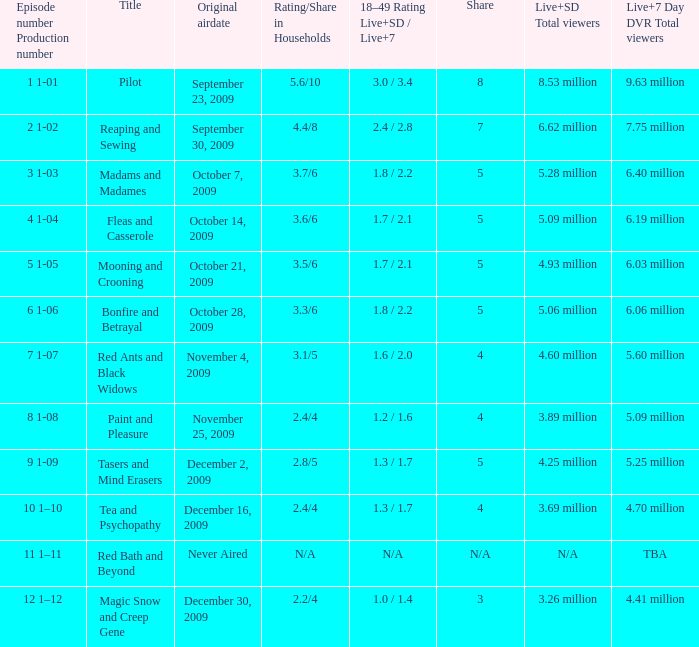When did the episode that had 3.69 million total viewers (Live and SD types combined) first air? December 16, 2009. 